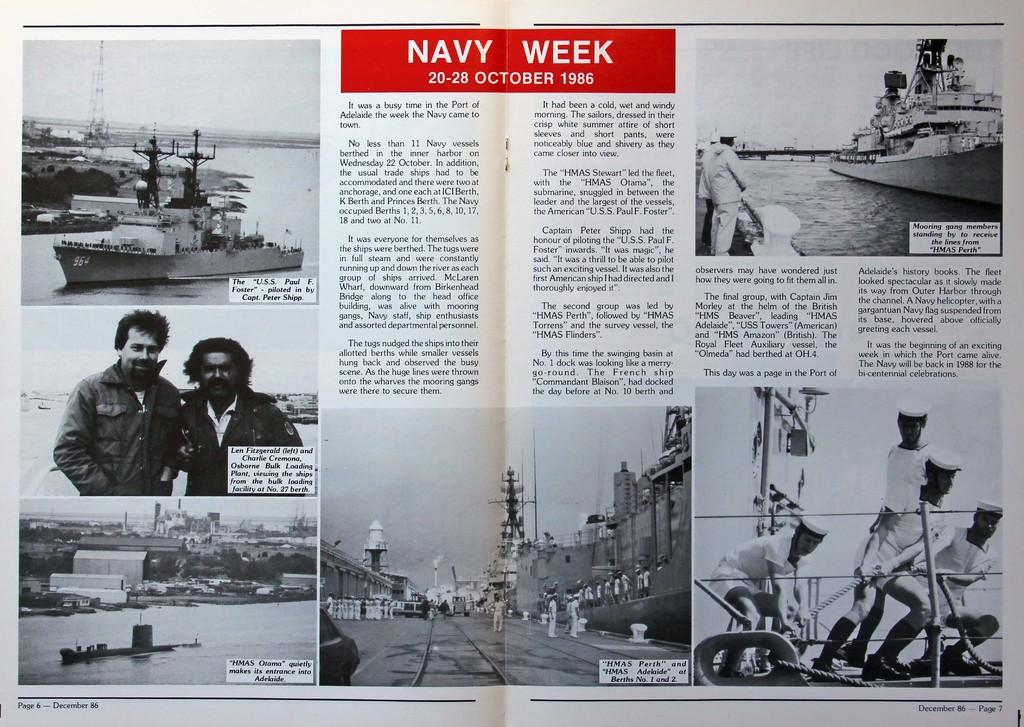What type of content is depicted on the page in the image? The images on the page are related to the navy. Can you describe the layout of the page? The page appears to be a page from a book, with images and a description about the images in the middle of the page. What type of rice is being cooked in the image? There is no rice present in the image; it features images and a description related to the navy. Can you tell me how many snakes are visible in the image? There are no snakes visible in the image; it only contains images and a description related to the navy. 